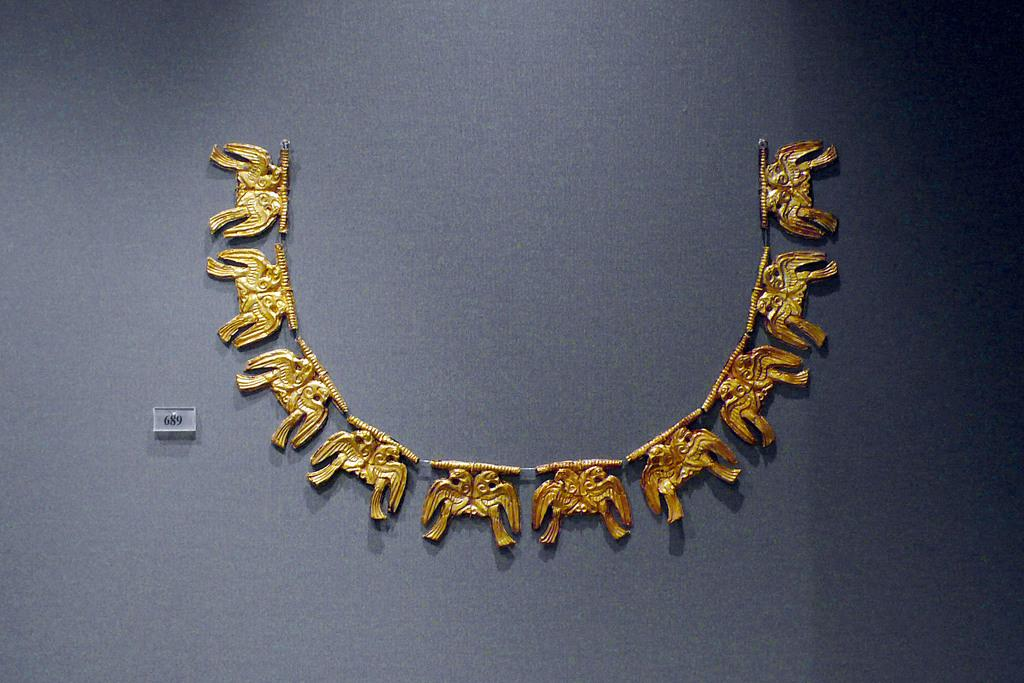What is the color of the background in the image? The background of the image is dark gray in color. What is the main subject in the middle of the image? There is a neck piece in the middle of the image. What is the color of the neck piece? The neck piece is gold in color. What type of leather material can be seen on the chair in the image? There is no chair present in the image, so it is not possible to determine the type of leather material. 